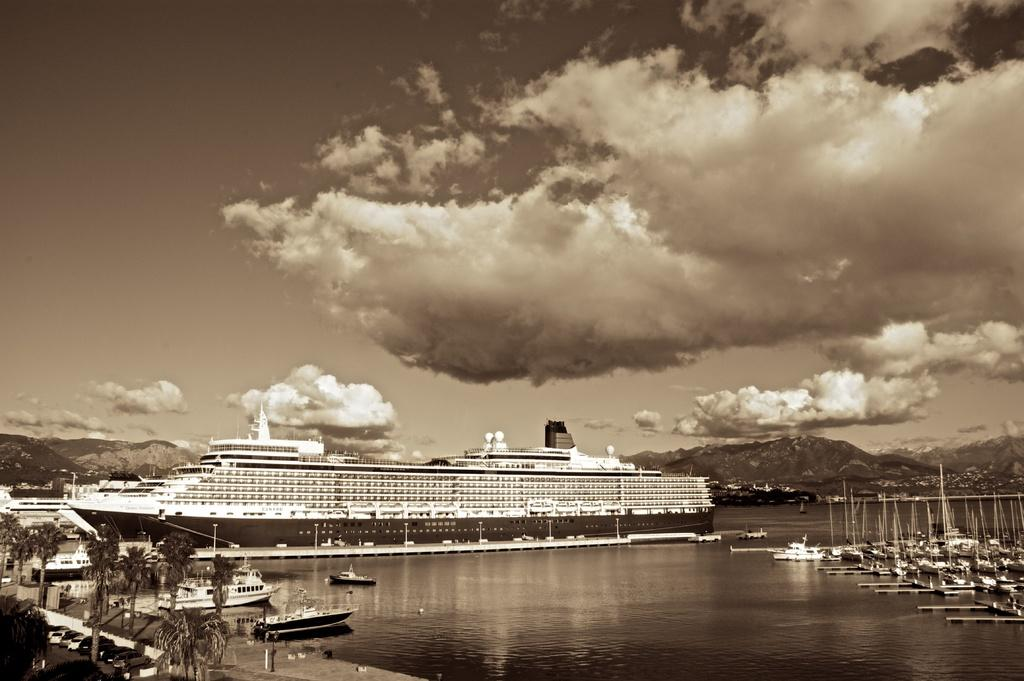What is the main subject of the image? There is a ship in the image. Are there any other watercraft visible in the image? Yes, there are many boats in the image. What is the setting of the image? There is water visible at the bottom of the image. What type of vegetation can be seen on the left side of the image? There are trees on the left side of the image. What is visible in the sky at the top of the image? There are clouds in the sky at the top of the image. What type of mist can be seen covering the ship in the image? There is no mist present in the image; the ship and boats are visible in clear water. 